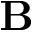<formula> <loc_0><loc_0><loc_500><loc_500>B</formula> 